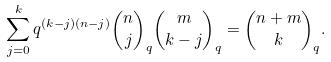<formula> <loc_0><loc_0><loc_500><loc_500>\sum _ { j = 0 } ^ { k } q ^ { ( k - j ) ( n - j ) } \binom { n } { j } _ { q } \binom { m } { k - j } _ { q } = \binom { n + m } { k } _ { q } .</formula> 